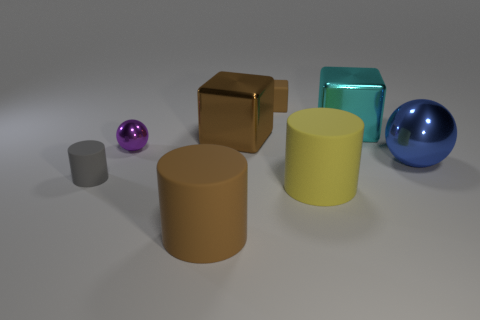Is the number of big brown cylinders that are behind the yellow rubber object the same as the number of brown cubes?
Offer a terse response. No. There is a cylinder that is behind the large yellow cylinder that is in front of the rubber cylinder that is to the left of the tiny purple shiny sphere; what is its material?
Keep it short and to the point. Rubber. There is a large cube that is the same color as the small cube; what is its material?
Give a very brief answer. Metal. What number of objects are either brown things that are in front of the gray object or cyan shiny objects?
Your answer should be very brief. 2. How many objects are either cyan objects or big shiny cubes right of the yellow rubber thing?
Ensure brevity in your answer.  1. How many tiny things are right of the small matte object that is in front of the metallic ball that is right of the yellow rubber cylinder?
Provide a short and direct response. 2. There is a sphere that is the same size as the yellow rubber cylinder; what is it made of?
Your answer should be compact. Metal. Are there any green objects that have the same size as the purple thing?
Provide a short and direct response. No. The tiny shiny object is what color?
Offer a very short reply. Purple. What is the color of the big rubber object to the left of the object behind the cyan cube?
Ensure brevity in your answer.  Brown. 